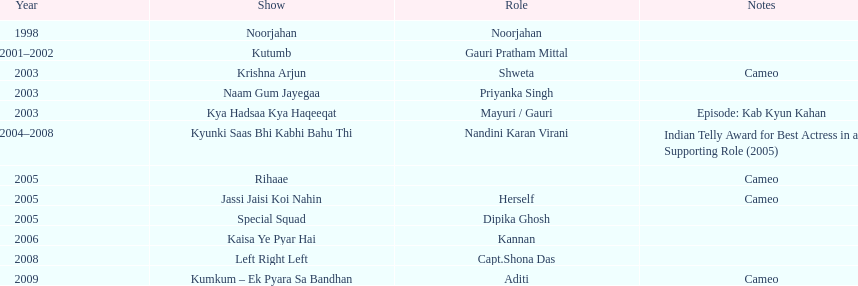In how many unique tv series did gauri tejwani appear before the year 2000? 1. 